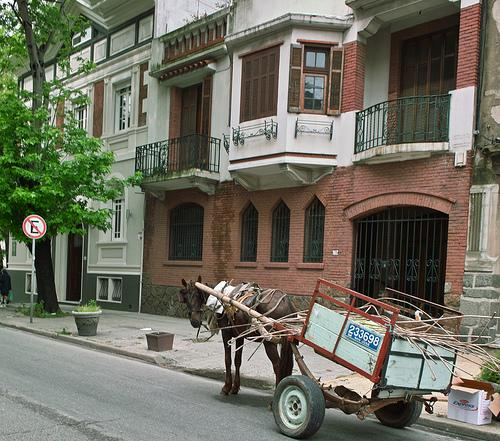Why is the horse attached to the cart with wheels? to pull 